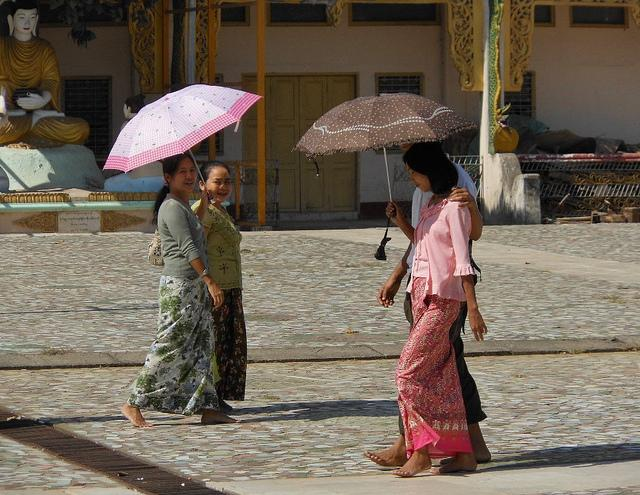Why are umbrellas being used today?

Choices:
A) snow
B) rain
C) sun
D) privacy sun 